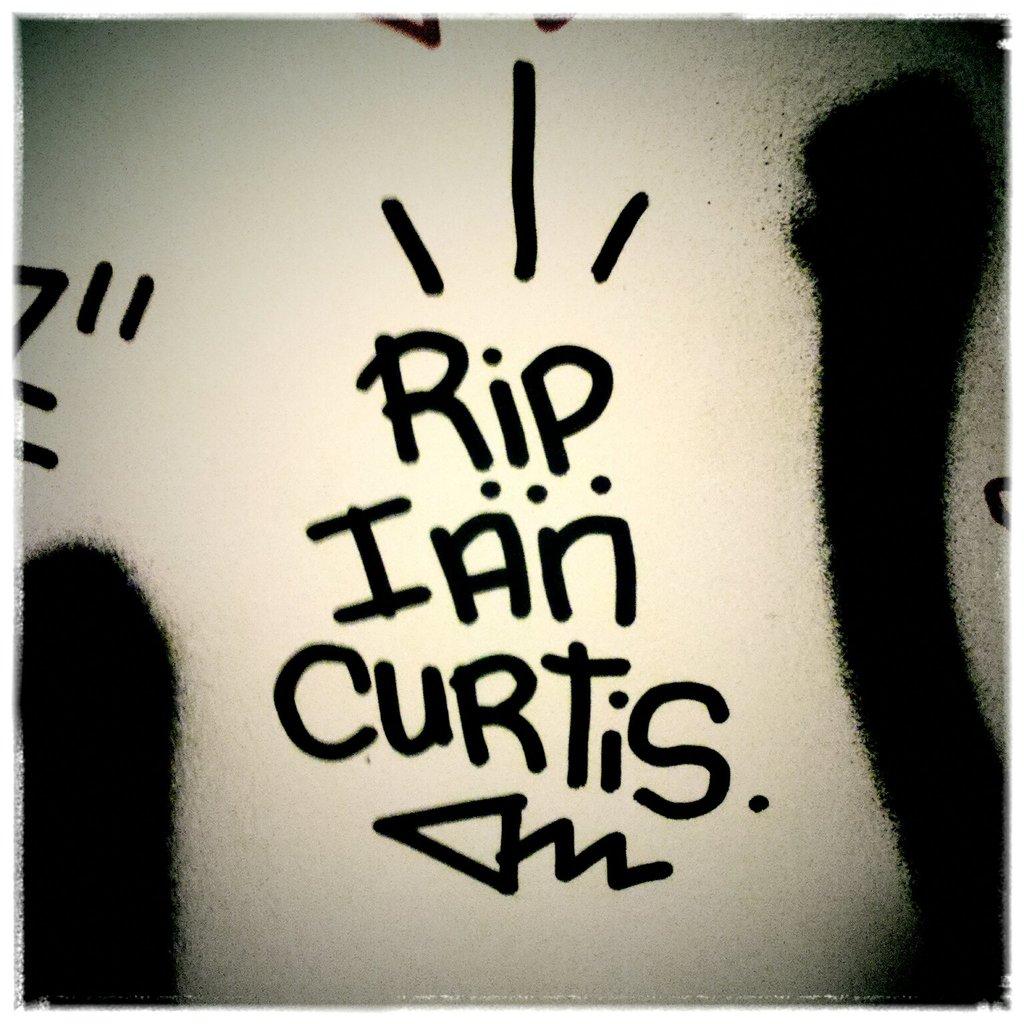Is ian curtis dead?
Your answer should be very brief. Yes. 